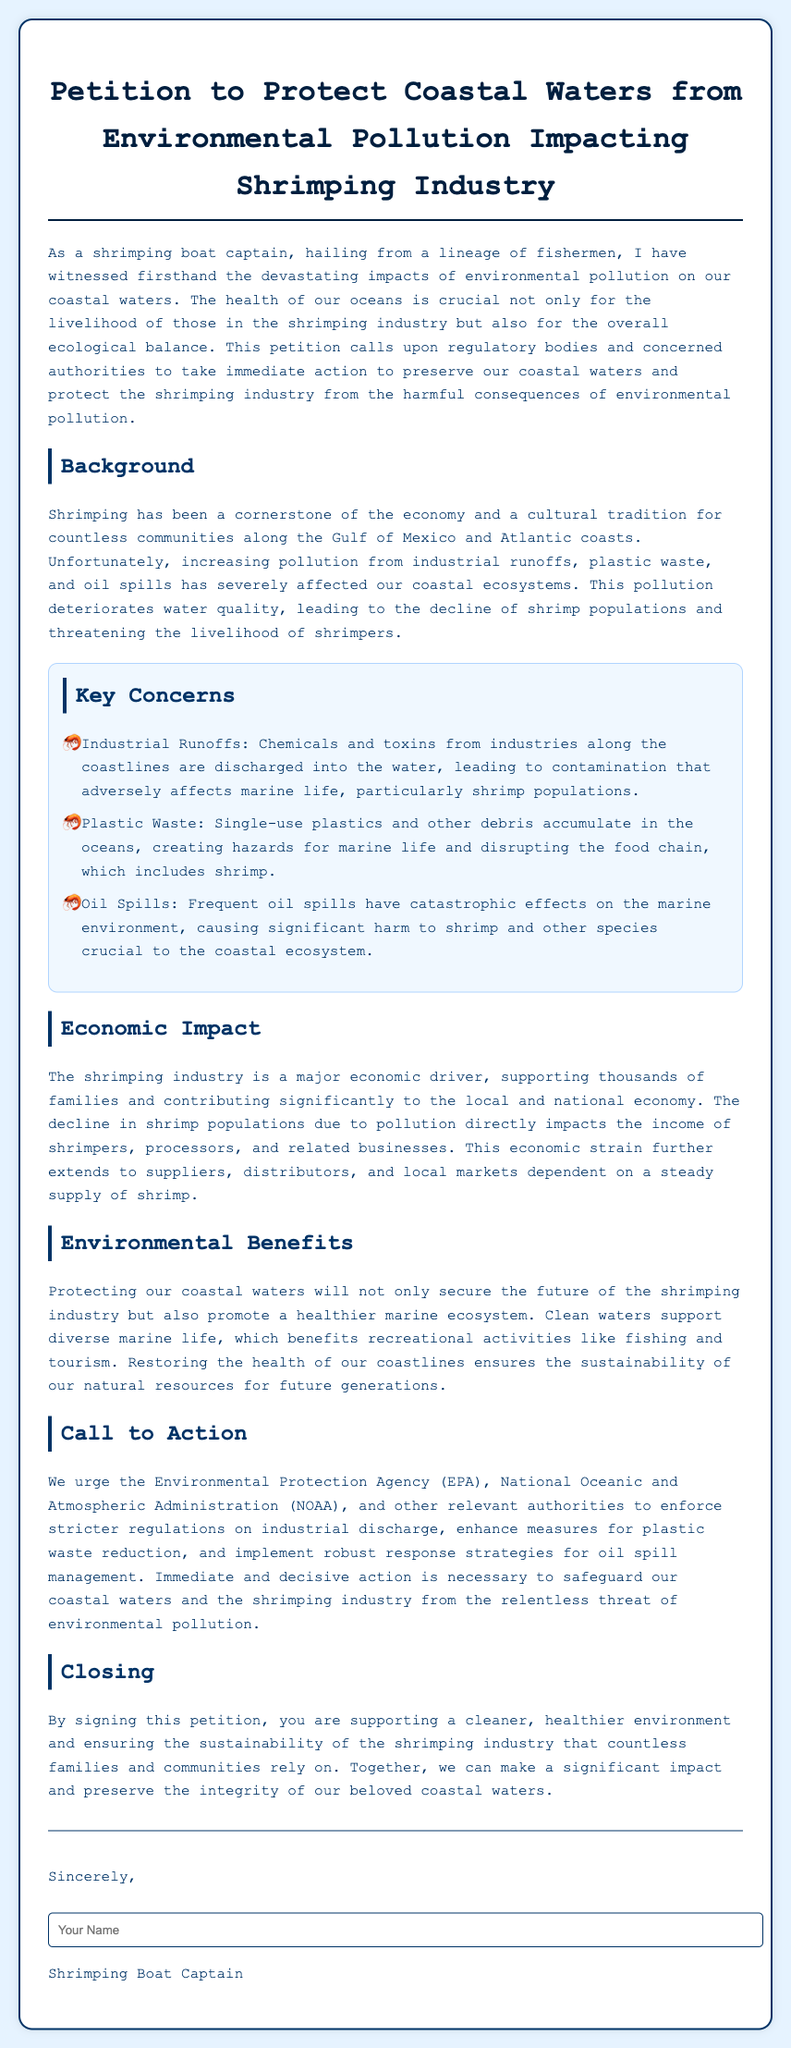What is the title of the petition? The title of the petition is explicitly mentioned in the document.
Answer: Petition to Protect Coastal Waters from Environmental Pollution Impacting Shrimping Industry What is the primary concern regarding industrial runoffs? The document provides a specific concern related to industrial runoffs impacting marine life.
Answer: Contamination affecting shrimp populations Which three key concerns are addressed in the petition? The petition outlines three concerns which are clearly listed.
Answer: Industrial Runoffs, Plastic Waste, Oil Spills What is the economic impact mentioned in the petition? The petition states the economic consequences of pollution on shrimping.
Answer: The decline in shrimp populations impacts income What regulatory bodies are urged to take action? The document identifies specific agencies to target for action.
Answer: Environmental Protection Agency (EPA), National Oceanic and Atmospheric Administration (NOAA) What can signing the petition contribute to? The document concludes with a statement about the benefits of signing.
Answer: A cleaner, healthier environment How does pollution affect recreational activities? The document discusses implications for recreational activities due to pollution.
Answer: Disrupts marine ecosystems and tourism What culturally significant role does shrimping play? The background section of the petition indicates its importance.
Answer: A cornerstone of the economy and tradition What type of document is this? The format and purpose of the document allows for a specific classification.
Answer: Petition 